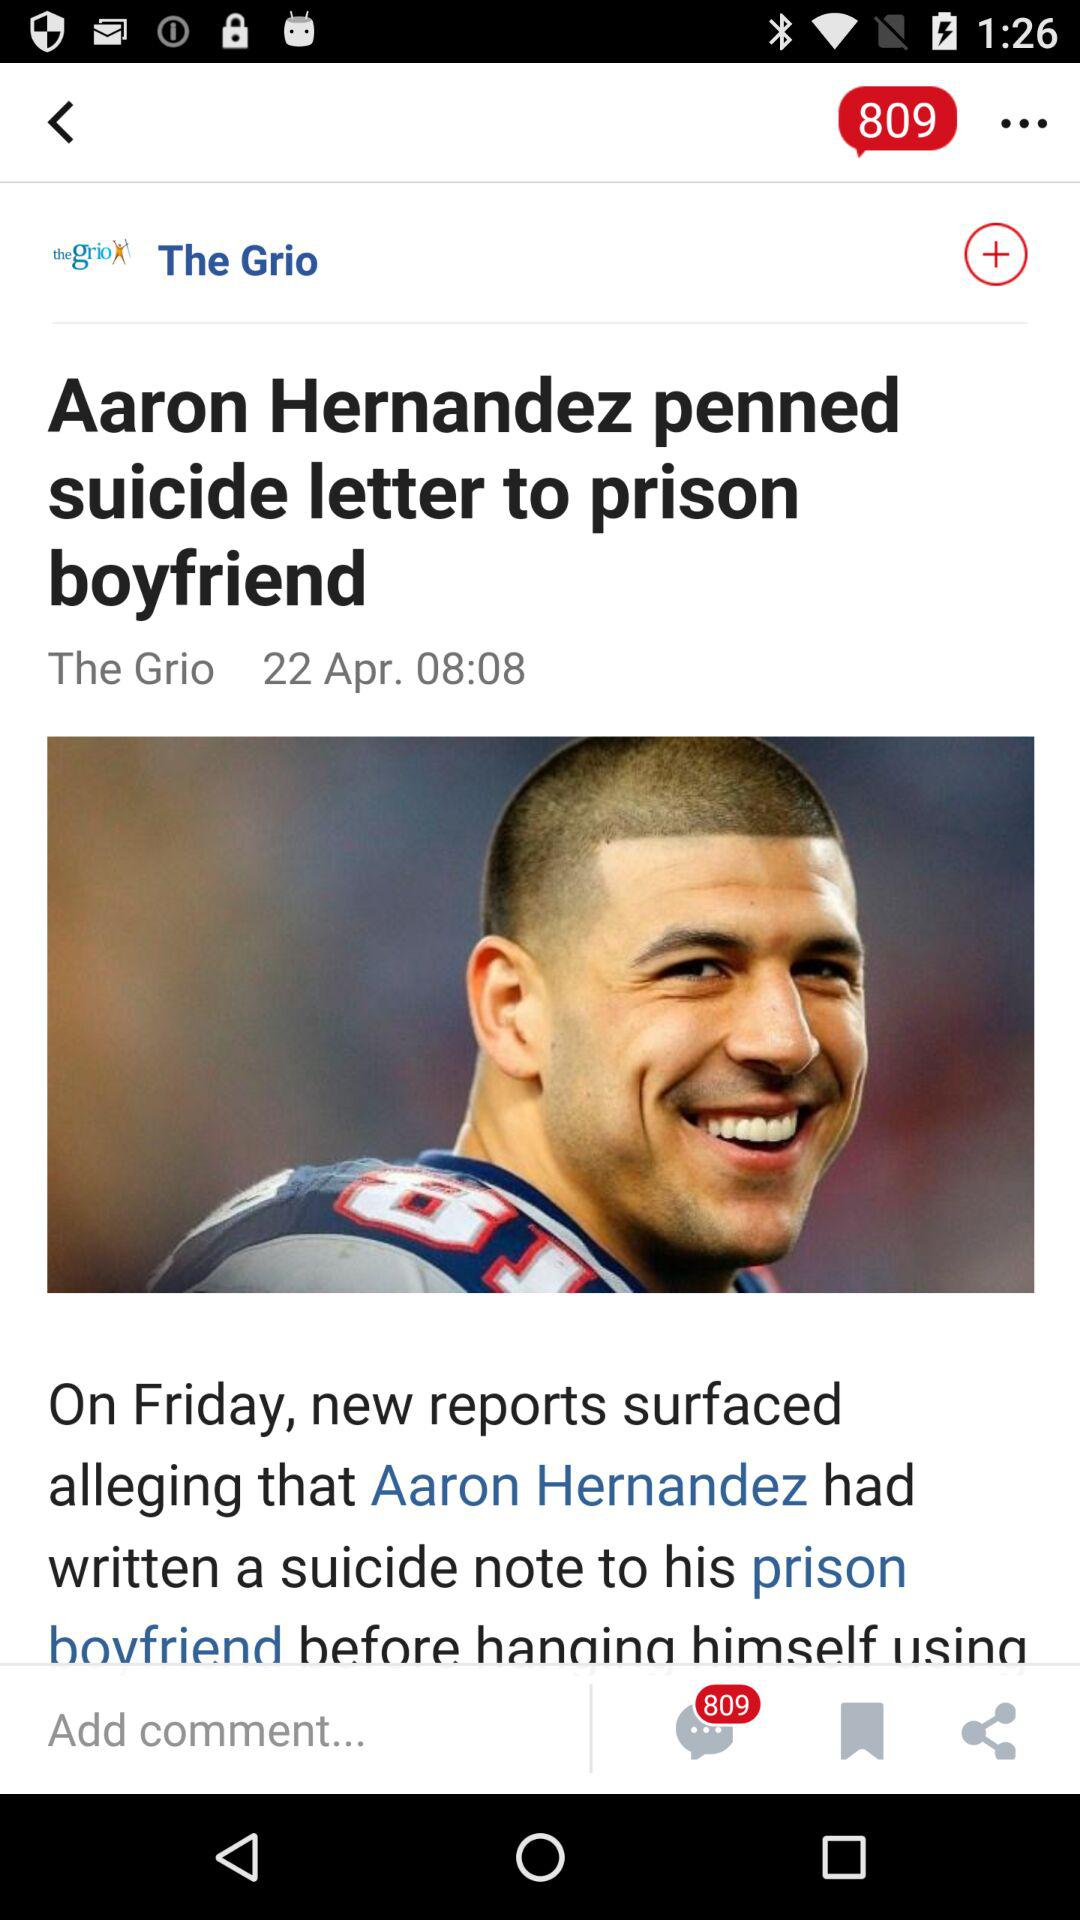What is the posted date of the news? The posted date of the news is April 22. 